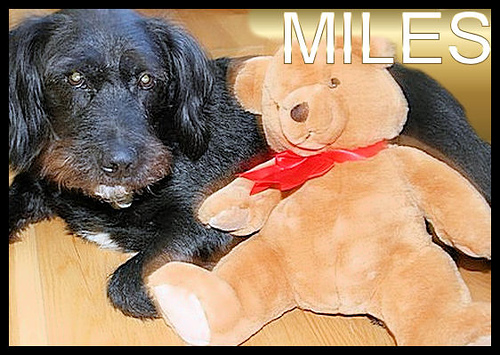<image>What sport does this dog play? It is ambiguous to determine what sport this dog plays. It can be baseball, frisbee, or catch. What sport does this dog play? I don't know what sport the dog plays. It can be seen playing baseball, frisbee or catch. 